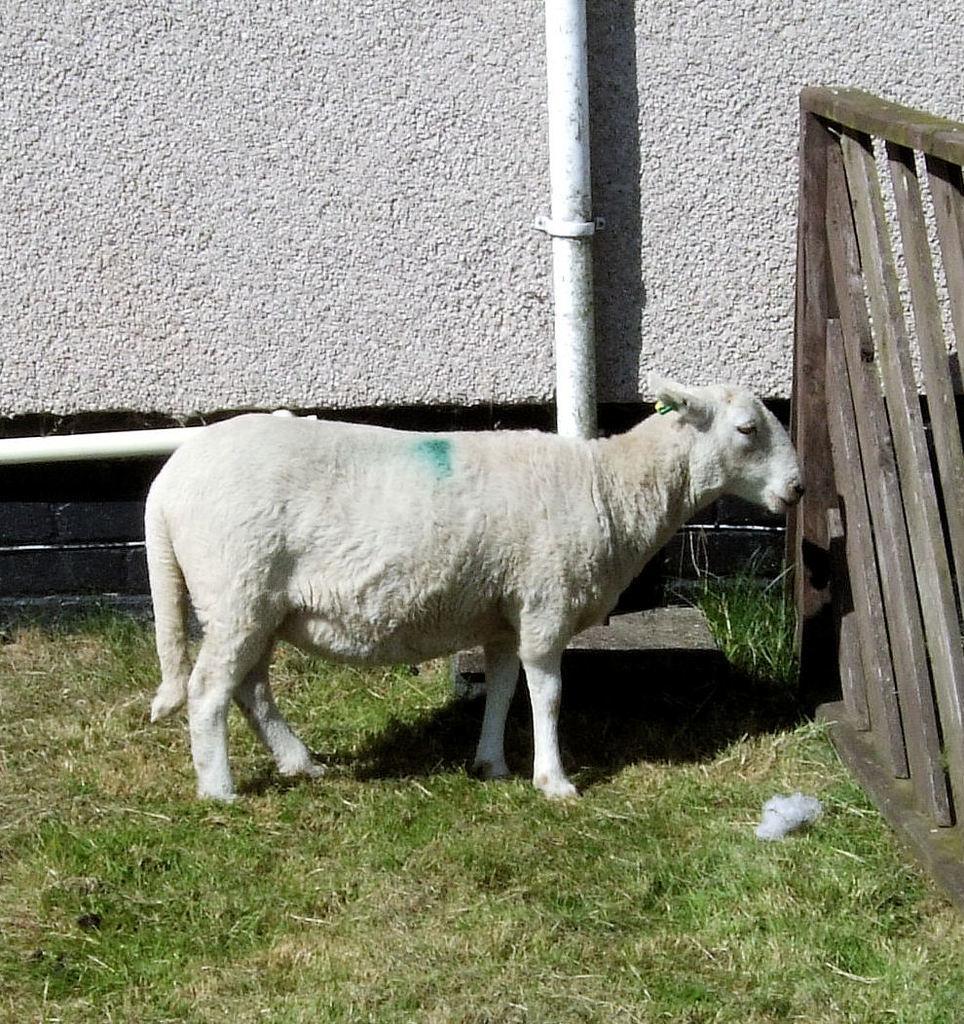Please provide a concise description of this image. In the foreground of this picture, there is a white sheep on the grass. On the right, there is a wooden fencing. On the top, there is a wall and a pipe. 